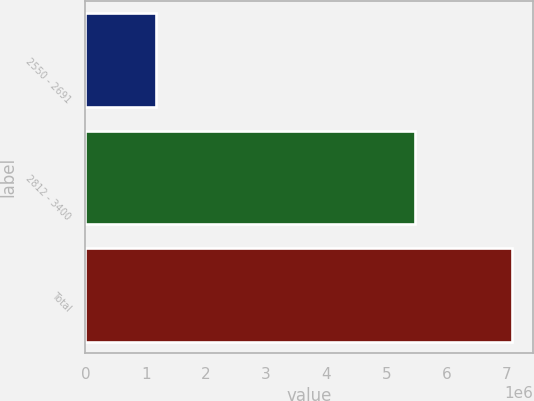<chart> <loc_0><loc_0><loc_500><loc_500><bar_chart><fcel>2550 - 2691<fcel>2812 - 3400<fcel>Total<nl><fcel>1.1662e+06<fcel>5.48028e+06<fcel>7.09118e+06<nl></chart> 